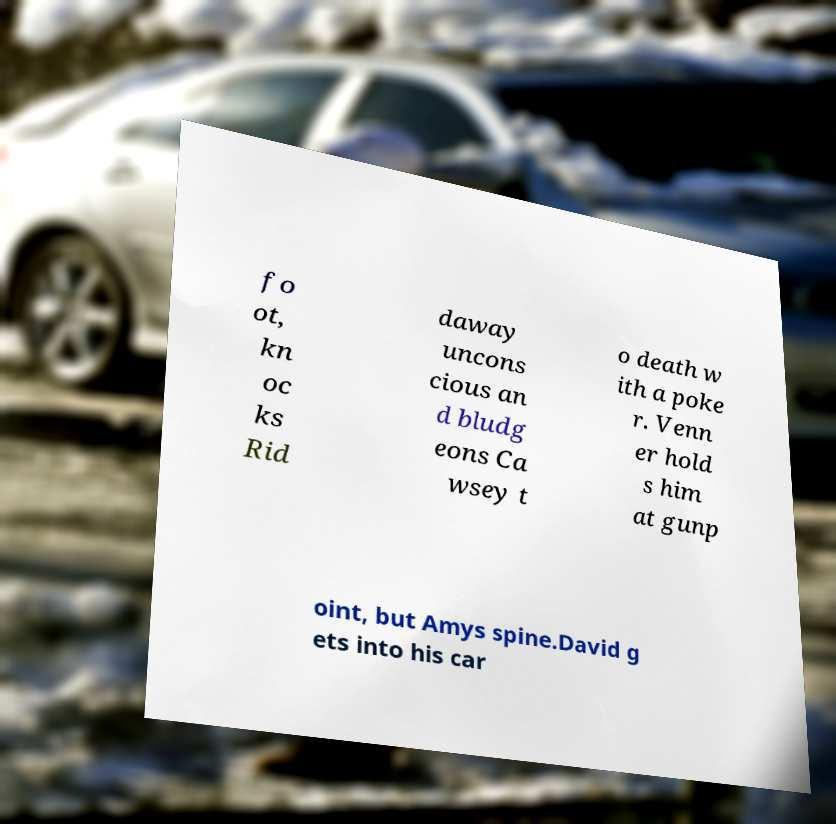Could you assist in decoding the text presented in this image and type it out clearly? fo ot, kn oc ks Rid daway uncons cious an d bludg eons Ca wsey t o death w ith a poke r. Venn er hold s him at gunp oint, but Amys spine.David g ets into his car 